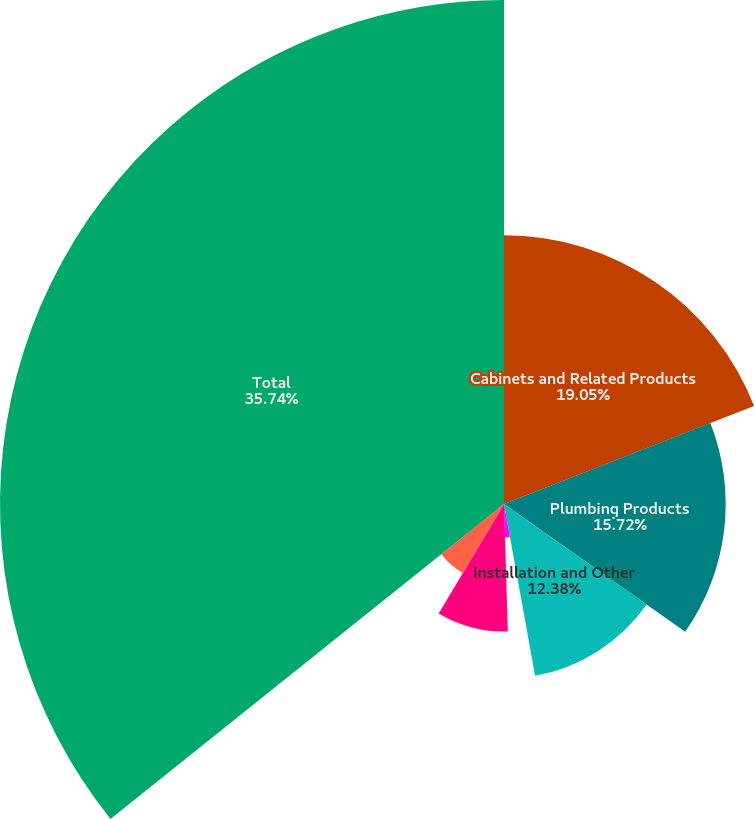Convert chart. <chart><loc_0><loc_0><loc_500><loc_500><pie_chart><fcel>Cabinets and Related Products<fcel>Plumbing Products<fcel>Installation and Other<fcel>Decorative Architectural<fcel>Other Specialty Products<fcel>Unallocated amounts<fcel>Total<nl><fcel>19.05%<fcel>15.72%<fcel>12.38%<fcel>2.37%<fcel>9.04%<fcel>5.7%<fcel>35.74%<nl></chart> 